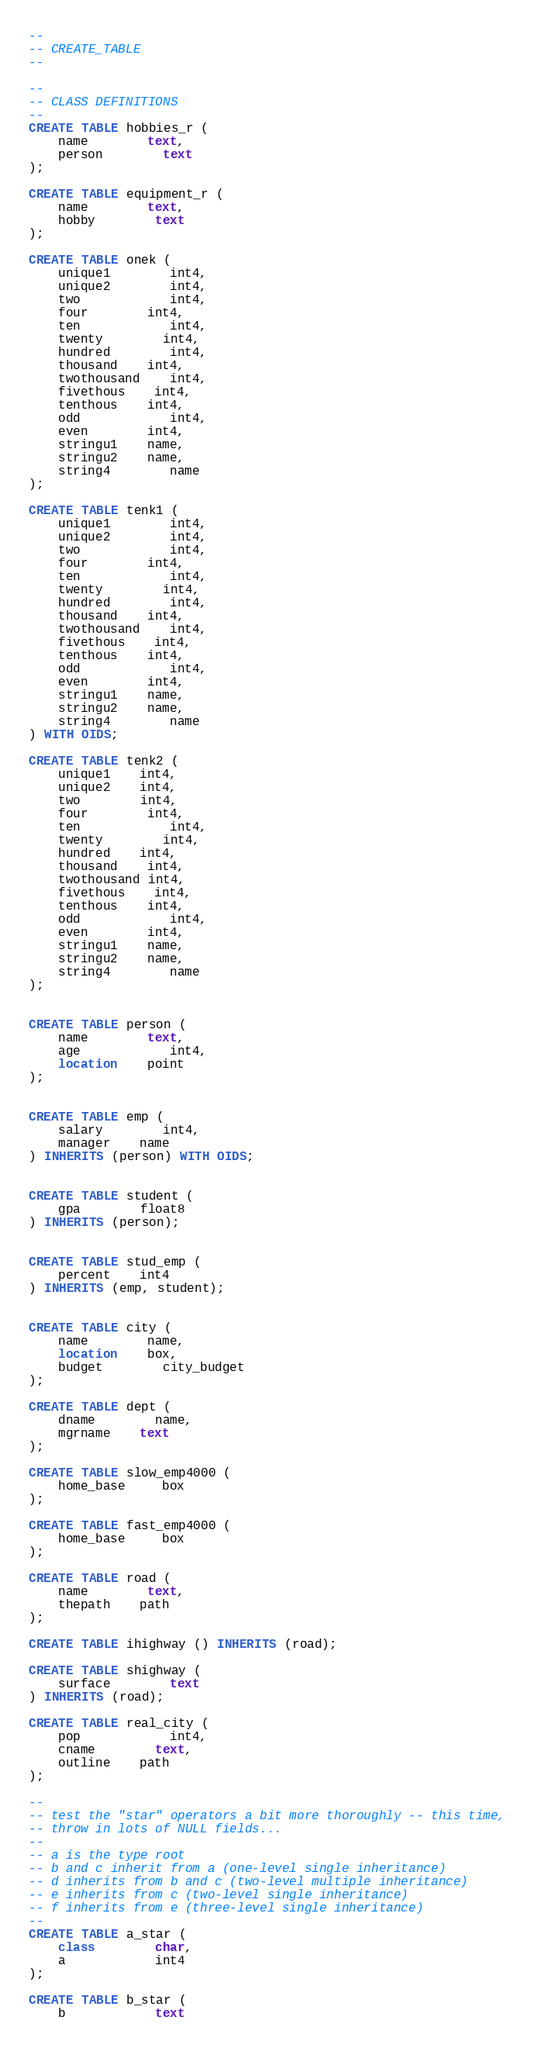<code> <loc_0><loc_0><loc_500><loc_500><_SQL_>--
-- CREATE_TABLE
--

--
-- CLASS DEFINITIONS
--
CREATE TABLE hobbies_r (
	name		text,
	person 		text
);

CREATE TABLE equipment_r (
	name 		text,
	hobby		text
);

CREATE TABLE onek (
	unique1		int4,
	unique2		int4,
	two			int4,
	four		int4,
	ten			int4,
	twenty		int4,
	hundred		int4,
	thousand	int4,
	twothousand	int4,
	fivethous	int4,
	tenthous	int4,
	odd			int4,
	even		int4,
	stringu1	name,
	stringu2	name,
	string4		name
);

CREATE TABLE tenk1 (
	unique1		int4,
	unique2		int4,
	two			int4,
	four		int4,
	ten			int4,
	twenty		int4,
	hundred		int4,
	thousand	int4,
	twothousand	int4,
	fivethous	int4,
	tenthous	int4,
	odd			int4,
	even		int4,
	stringu1	name,
	stringu2	name,
	string4		name
) WITH OIDS;

CREATE TABLE tenk2 (
	unique1 	int4,
	unique2 	int4,
	two 	 	int4,
	four 		int4,
	ten			int4,
	twenty 		int4,
	hundred 	int4,
	thousand 	int4,
	twothousand int4,
	fivethous 	int4,
	tenthous	int4,
	odd			int4,
	even		int4,
	stringu1	name,
	stringu2	name,
	string4		name
);


CREATE TABLE person (
	name 		text,
	age			int4,
	location 	point
);


CREATE TABLE emp (
	salary 		int4,
	manager 	name
) INHERITS (person) WITH OIDS;


CREATE TABLE student (
	gpa 		float8
) INHERITS (person);


CREATE TABLE stud_emp (
	percent 	int4
) INHERITS (emp, student);


CREATE TABLE city (
	name		name,
	location 	box,
	budget 		city_budget
);

CREATE TABLE dept (
	dname		name,
	mgrname 	text
);

CREATE TABLE slow_emp4000 (
	home_base	 box
);

CREATE TABLE fast_emp4000 (
	home_base	 box
);

CREATE TABLE road (
	name		text,
	thepath 	path
);

CREATE TABLE ihighway () INHERITS (road);

CREATE TABLE shighway (
	surface		text
) INHERITS (road);

CREATE TABLE real_city (
	pop			int4,
	cname		text,
	outline 	path
);

--
-- test the "star" operators a bit more thoroughly -- this time,
-- throw in lots of NULL fields...
--
-- a is the type root
-- b and c inherit from a (one-level single inheritance)
-- d inherits from b and c (two-level multiple inheritance)
-- e inherits from c (two-level single inheritance)
-- f inherits from e (three-level single inheritance)
--
CREATE TABLE a_star (
	class		char,
	a 			int4
);

CREATE TABLE b_star (
	b 			text</code> 